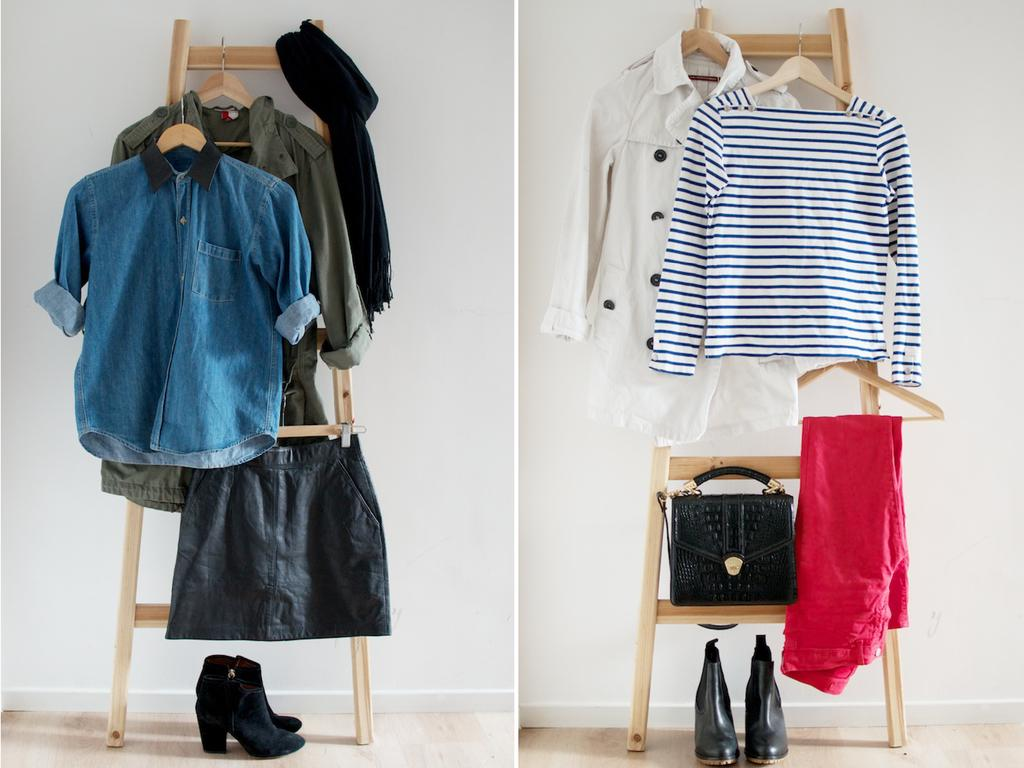What is the main subject of the image? The main subject of the image is clothes hanging on wooden poles. Can you describe the clothes that are visible? The clothes include a blue t-shirt, an ash-colored shirt, a red item (possibly a shirt or a bag), and a pair of boots. What can be seen in the background of the image? There is a white wall visible in the background. From which floor was the image taken? The image is taken from the bottom floor. What type of memory is stored in the boots in the image? There is no indication in the image that the boots or any other items have memory storage capabilities. How does the spark from the red item in the image affect the clothes hanging nearby? There is no spark present in the image, and therefore no effect on the clothes. 